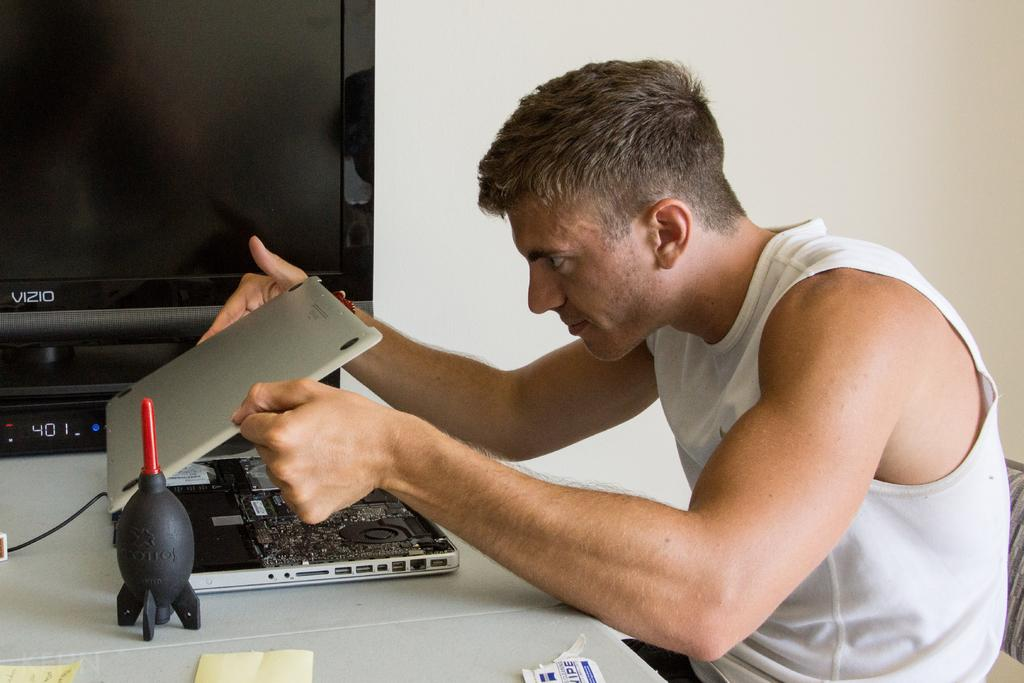What is the man in the image holding? The man is holding a laptop. What is on the table in front of the man? There are papers and an object on the table in front of the man. What can be seen in the background of the image? There is a television and a wall in the background of the image. What time of day is recess happening in the image? There is no indication of a recess or time of day in the image; it simply shows a man holding a laptop with papers and an object on the table in front of him, and a television and wall in the background. 